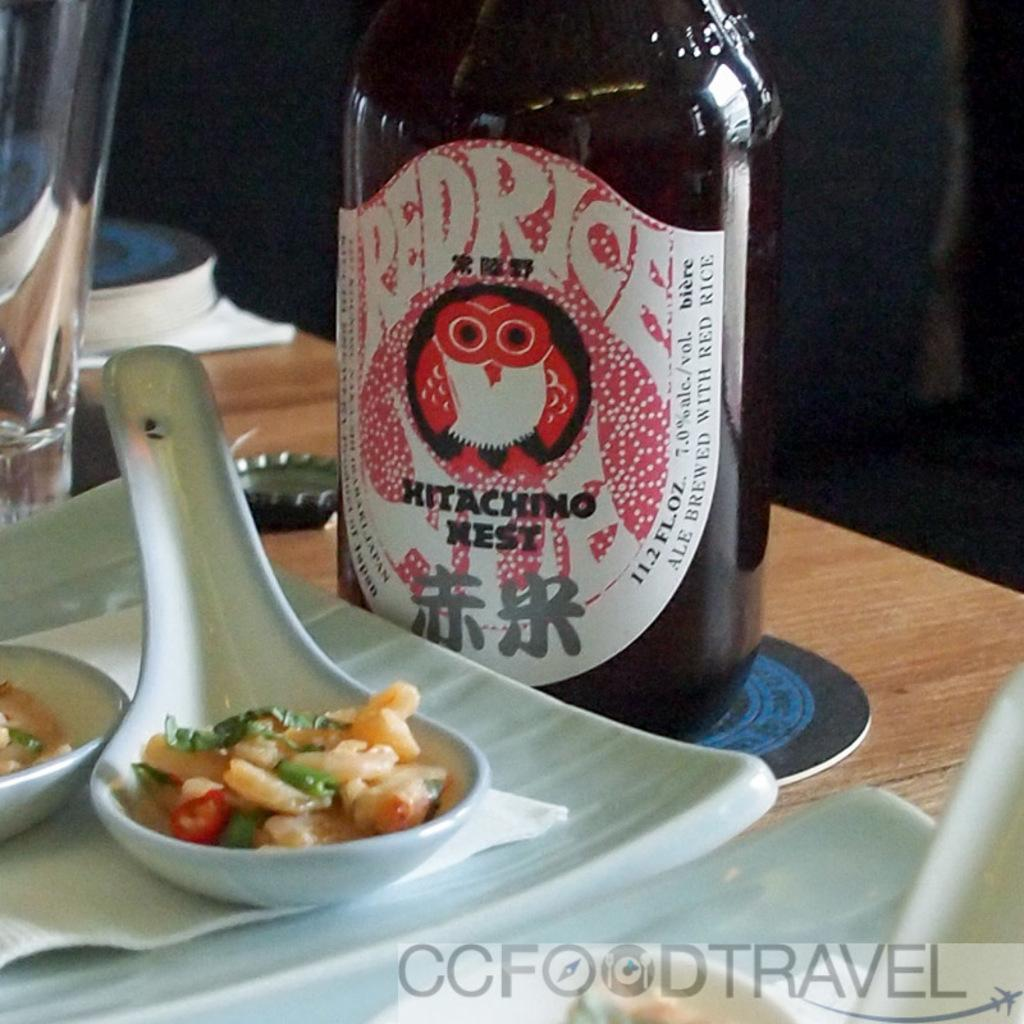What piece of furniture is present in the image? There is a table in the image. What objects are placed on the table? There are two white plates on the table. Is there any cutlery visible in the image? Yes, there is a white spoon in one of the plates. What type of container is on the table? There is a bottle on the table. What type of key is used to open the bottle in the image? There is no key present in the image, and the bottle does not require a key to open. 